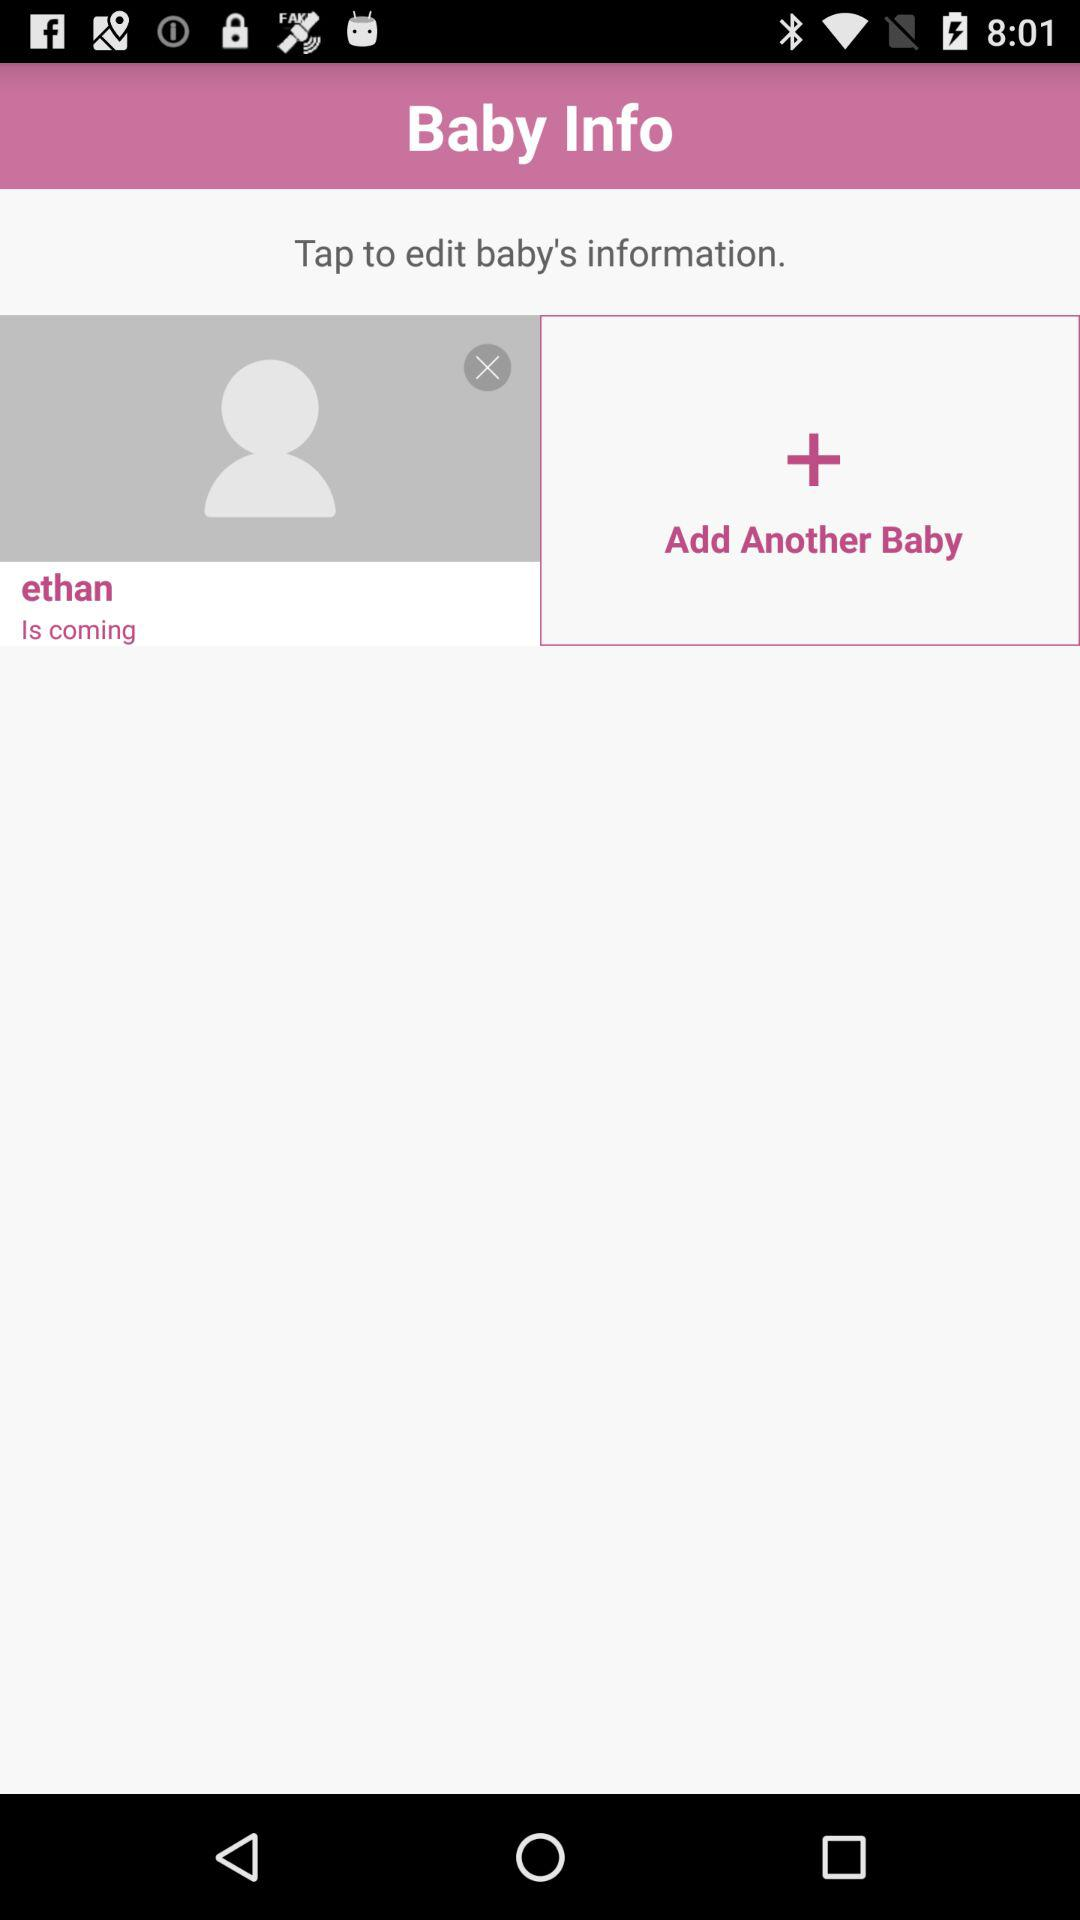Who is coming? The baby who is coming is Ethan. 